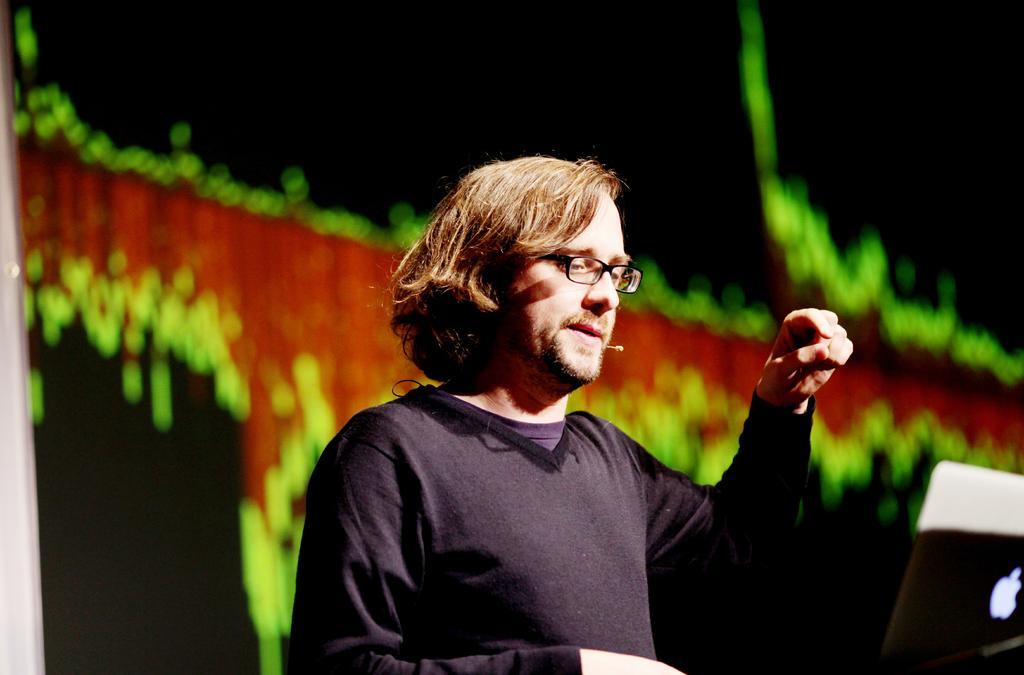Please provide a concise description of this image. In this image we can see a person wearing the spectacles and mic, in front of him there is a laptop and in the background we can see some colors. 